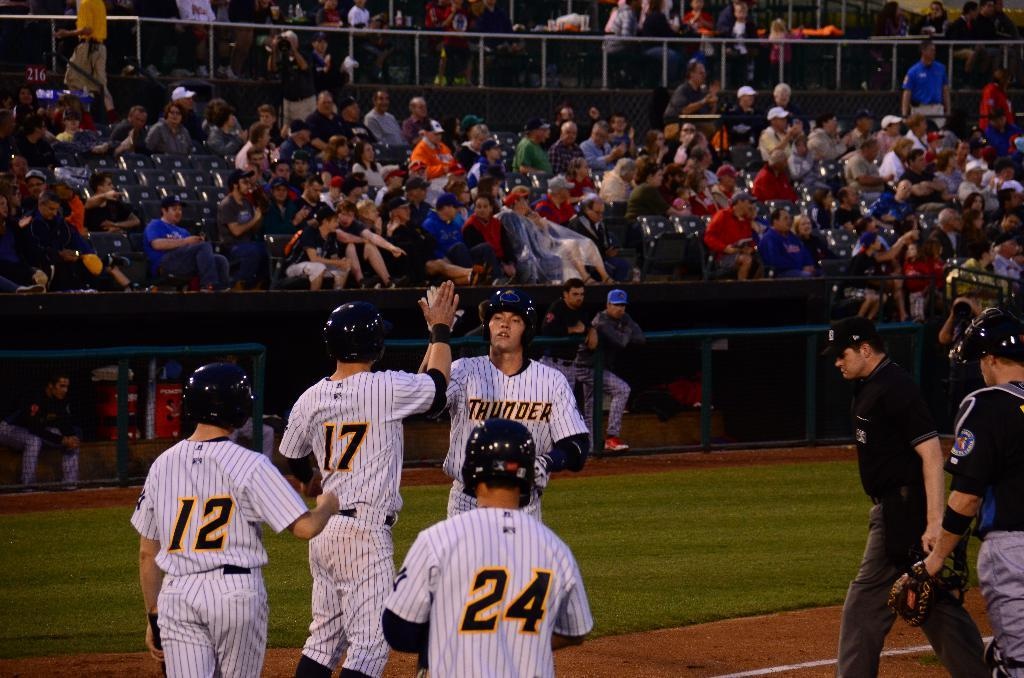<image>
Provide a brief description of the given image. Four baseball players with numbers 12, 24 and 17 are on the field during a baseball game. 